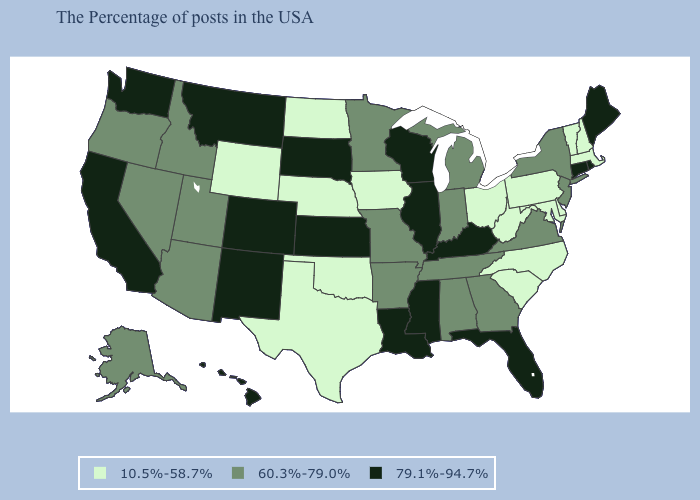Does West Virginia have a lower value than Hawaii?
Keep it brief. Yes. Does New Hampshire have the lowest value in the Northeast?
Keep it brief. Yes. Which states have the lowest value in the South?
Write a very short answer. Delaware, Maryland, North Carolina, South Carolina, West Virginia, Oklahoma, Texas. Name the states that have a value in the range 10.5%-58.7%?
Concise answer only. Massachusetts, New Hampshire, Vermont, Delaware, Maryland, Pennsylvania, North Carolina, South Carolina, West Virginia, Ohio, Iowa, Nebraska, Oklahoma, Texas, North Dakota, Wyoming. What is the value of Vermont?
Concise answer only. 10.5%-58.7%. Name the states that have a value in the range 60.3%-79.0%?
Keep it brief. New York, New Jersey, Virginia, Georgia, Michigan, Indiana, Alabama, Tennessee, Missouri, Arkansas, Minnesota, Utah, Arizona, Idaho, Nevada, Oregon, Alaska. Does Maryland have the lowest value in the USA?
Write a very short answer. Yes. What is the lowest value in the MidWest?
Write a very short answer. 10.5%-58.7%. What is the value of Kansas?
Quick response, please. 79.1%-94.7%. Does Minnesota have a lower value than Rhode Island?
Give a very brief answer. Yes. Does West Virginia have the same value as New Hampshire?
Write a very short answer. Yes. Name the states that have a value in the range 10.5%-58.7%?
Be succinct. Massachusetts, New Hampshire, Vermont, Delaware, Maryland, Pennsylvania, North Carolina, South Carolina, West Virginia, Ohio, Iowa, Nebraska, Oklahoma, Texas, North Dakota, Wyoming. Does California have a higher value than West Virginia?
Be succinct. Yes. Among the states that border Illinois , does Missouri have the highest value?
Give a very brief answer. No. Among the states that border Connecticut , does Rhode Island have the highest value?
Write a very short answer. Yes. 